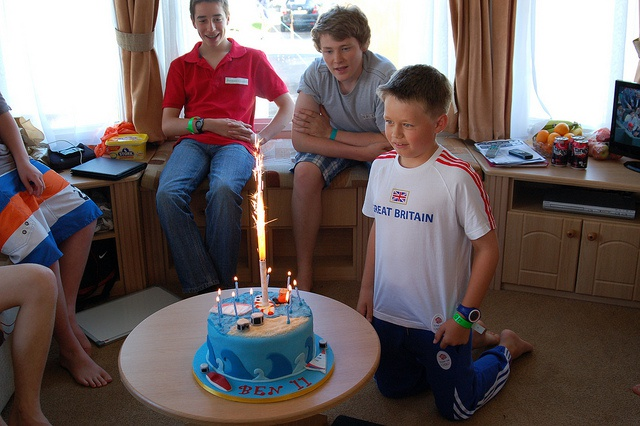Describe the objects in this image and their specific colors. I can see people in white, black, darkgray, gray, and maroon tones, dining table in white, gray, blue, and teal tones, people in white, black, brown, and maroon tones, people in white, gray, maroon, black, and brown tones, and people in white, maroon, black, gray, and navy tones in this image. 